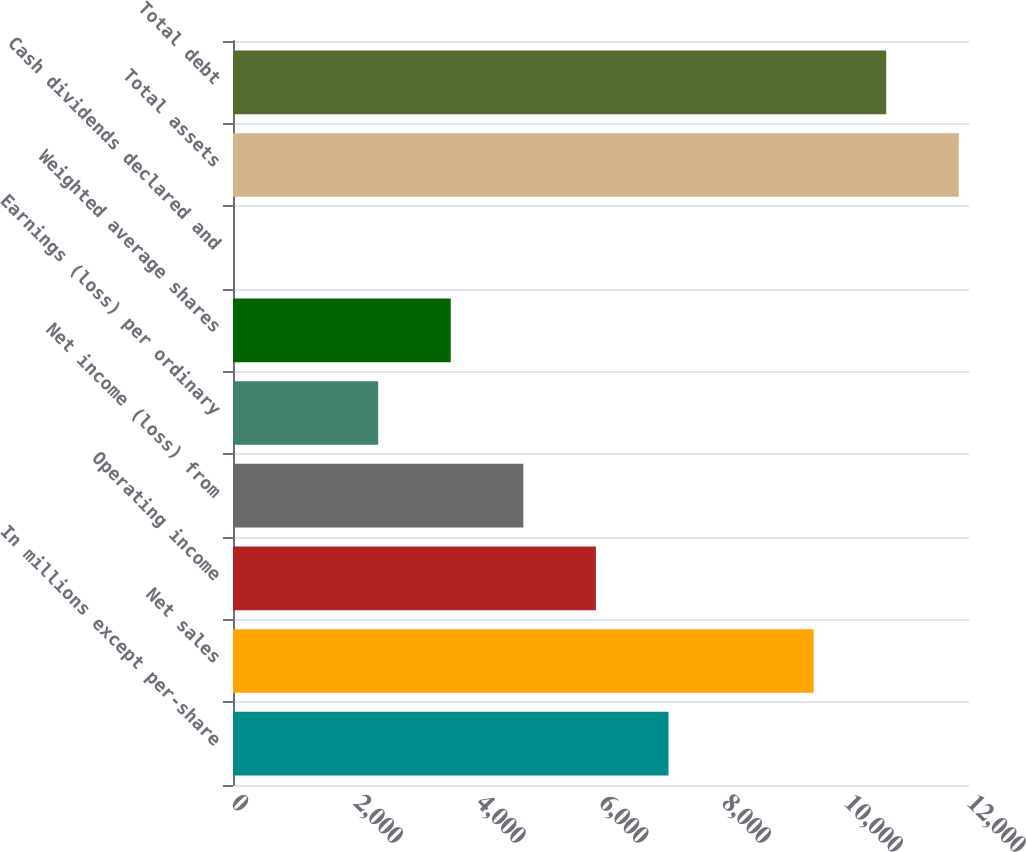<chart> <loc_0><loc_0><loc_500><loc_500><bar_chart><fcel>In millions except per-share<fcel>Net sales<fcel>Operating income<fcel>Net income (loss) from<fcel>Earnings (loss) per ordinary<fcel>Weighted average shares<fcel>Cash dividends declared and<fcel>Total assets<fcel>Total debt<nl><fcel>7100.25<fcel>9466.89<fcel>5916.93<fcel>4733.61<fcel>2366.97<fcel>3550.29<fcel>0.33<fcel>11833.5<fcel>10650.2<nl></chart> 